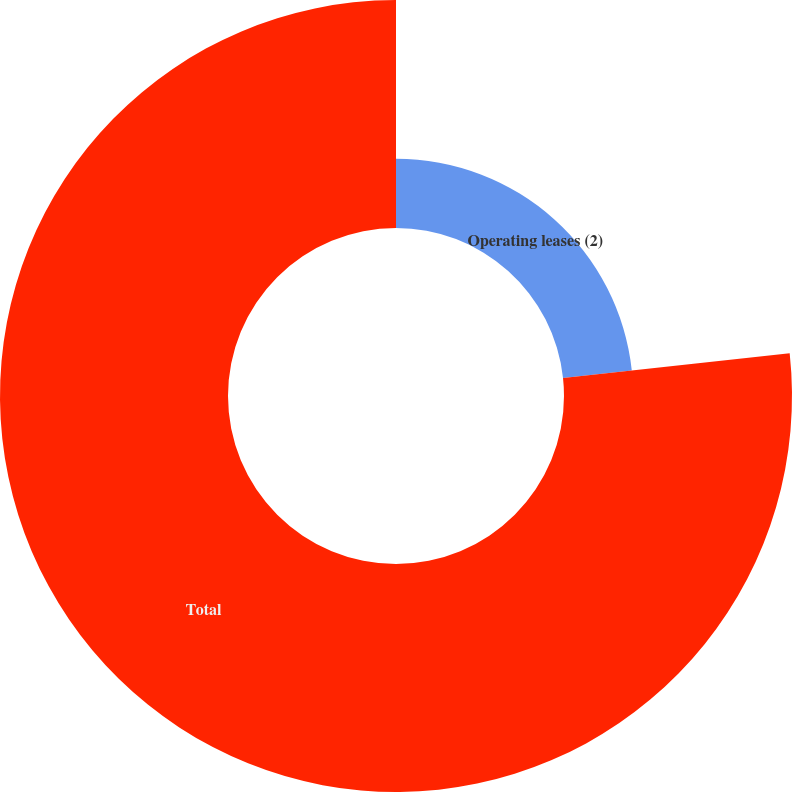Convert chart. <chart><loc_0><loc_0><loc_500><loc_500><pie_chart><fcel>Operating leases (2)<fcel>Total<nl><fcel>23.28%<fcel>76.72%<nl></chart> 